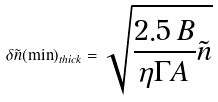<formula> <loc_0><loc_0><loc_500><loc_500>\delta \tilde { n } ( \min ) _ { t h i c k } = \sqrt { \frac { 2 . 5 \, B } { \eta \Gamma A } \tilde { n } }</formula> 